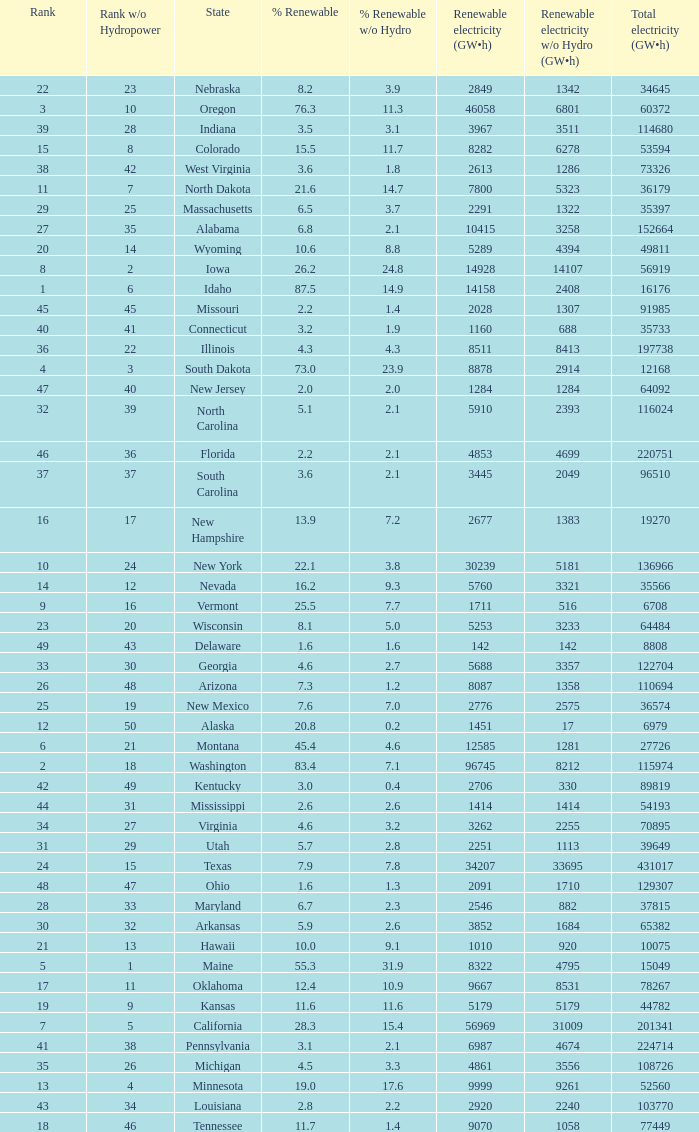Which states have renewable electricity equal to 9667 (gw×h)? Oklahoma. 